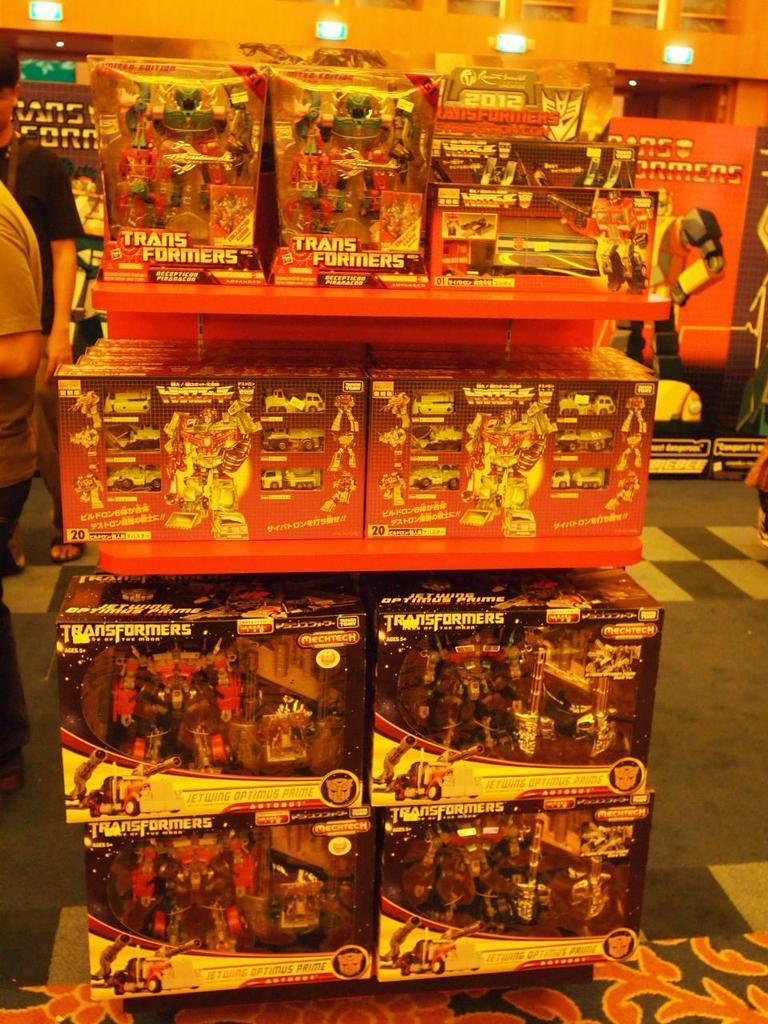How would you summarize this image in a sentence or two? In the foreground of this image, there are toy boxes in the shelf. On the left, there are two people on the floor. In the background, it seems like banners and few lights at the top. 